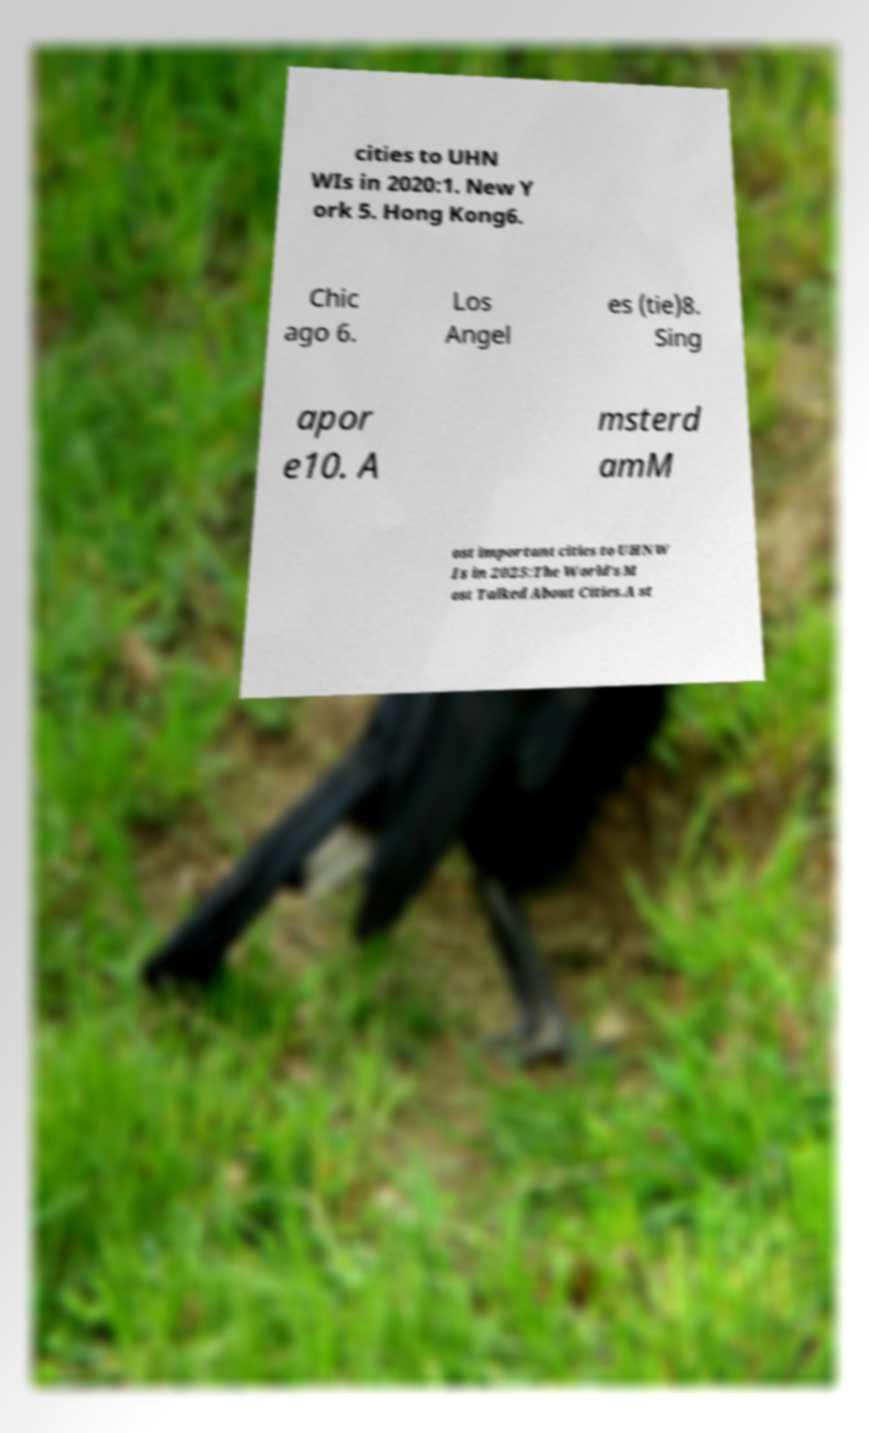Could you assist in decoding the text presented in this image and type it out clearly? cities to UHN WIs in 2020:1. New Y ork 5. Hong Kong6. Chic ago 6. Los Angel es (tie)8. Sing apor e10. A msterd amM ost important cities to UHNW Is in 2025:The World's M ost Talked About Cities.A st 